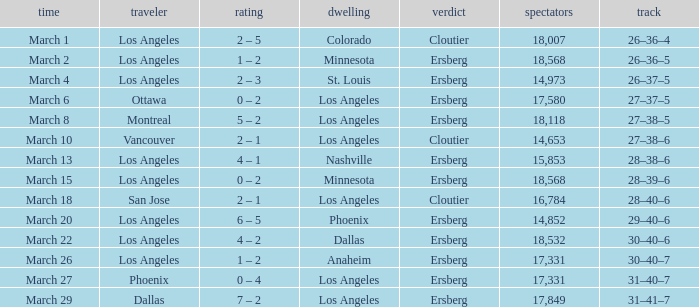On the Date of March 13, who was the Home team? Nashville. 